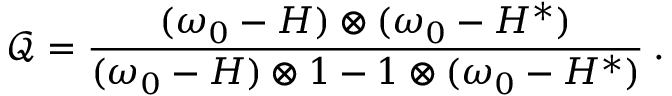Convert formula to latex. <formula><loc_0><loc_0><loc_500><loc_500>\mathcal { Q } = \frac { ( \omega _ { 0 } - H ) \otimes ( \omega _ { 0 } - H ^ { * } ) } { ( \omega _ { 0 } - H ) \otimes 1 - 1 \otimes ( \omega _ { 0 } - H ^ { * } ) } \, .</formula> 